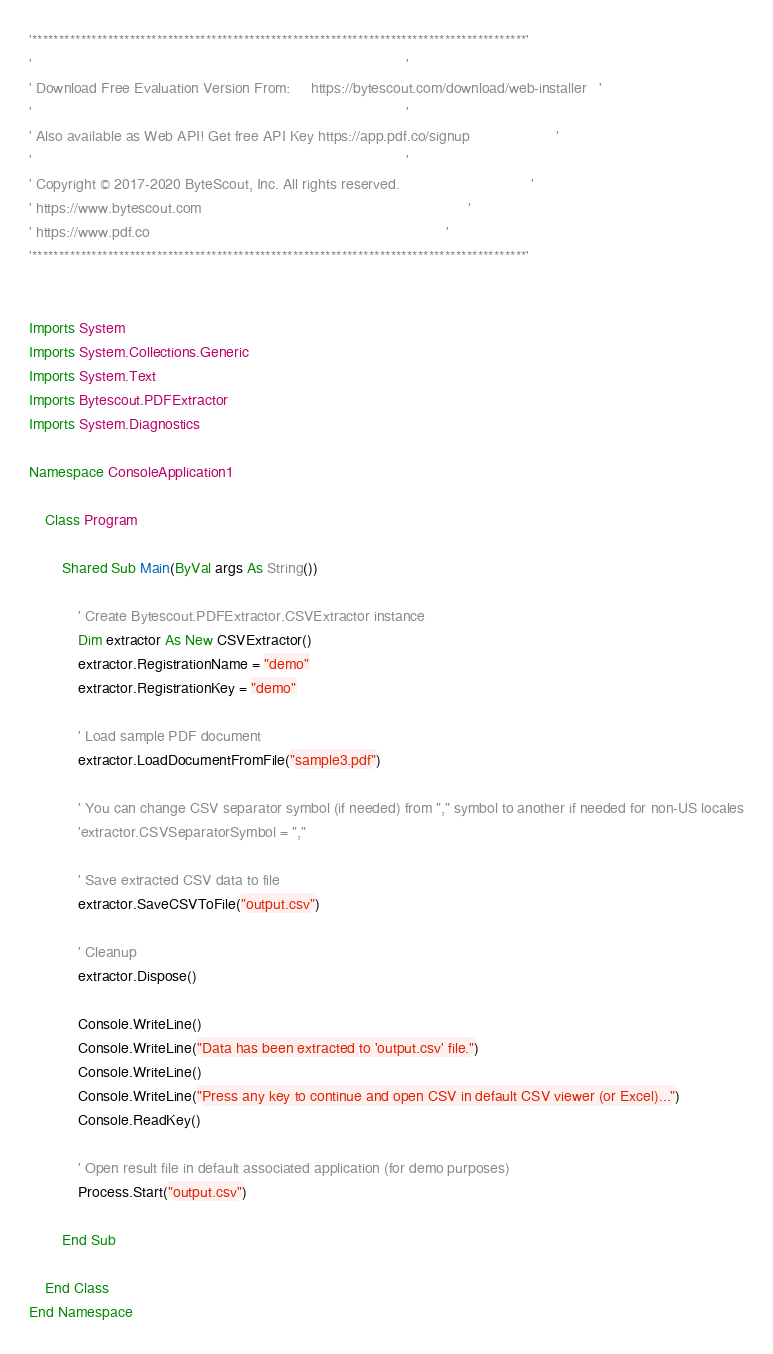<code> <loc_0><loc_0><loc_500><loc_500><_VisualBasic_>'*******************************************************************************************'
'                                                                                           '
' Download Free Evaluation Version From:     https://bytescout.com/download/web-installer   '
'                                                                                           '
' Also available as Web API! Get free API Key https://app.pdf.co/signup                     '
'                                                                                           '
' Copyright © 2017-2020 ByteScout, Inc. All rights reserved.                                '
' https://www.bytescout.com                                                                 '
' https://www.pdf.co                                                                        '
'*******************************************************************************************'


Imports System
Imports System.Collections.Generic
Imports System.Text
Imports Bytescout.PDFExtractor
Imports System.Diagnostics

Namespace ConsoleApplication1

    Class Program

        Shared Sub Main(ByVal args As String())

            ' Create Bytescout.PDFExtractor.CSVExtractor instance
            Dim extractor As New CSVExtractor()
            extractor.RegistrationName = "demo"
            extractor.RegistrationKey = "demo"

            ' Load sample PDF document
            extractor.LoadDocumentFromFile("sample3.pdf")

            ' You can change CSV separator symbol (if needed) from "," symbol to another if needed for non-US locales
            'extractor.CSVSeparatorSymbol = "," 

            ' Save extracted CSV data to file
            extractor.SaveCSVToFile("output.csv")

            ' Cleanup
		    extractor.Dispose()

            Console.WriteLine()
            Console.WriteLine("Data has been extracted to 'output.csv' file.")
            Console.WriteLine()
            Console.WriteLine("Press any key to continue and open CSV in default CSV viewer (or Excel)...")
            Console.ReadKey()

            ' Open result file in default associated application (for demo purposes)
            Process.Start("output.csv")

        End Sub
        
    End Class
End Namespace

</code> 